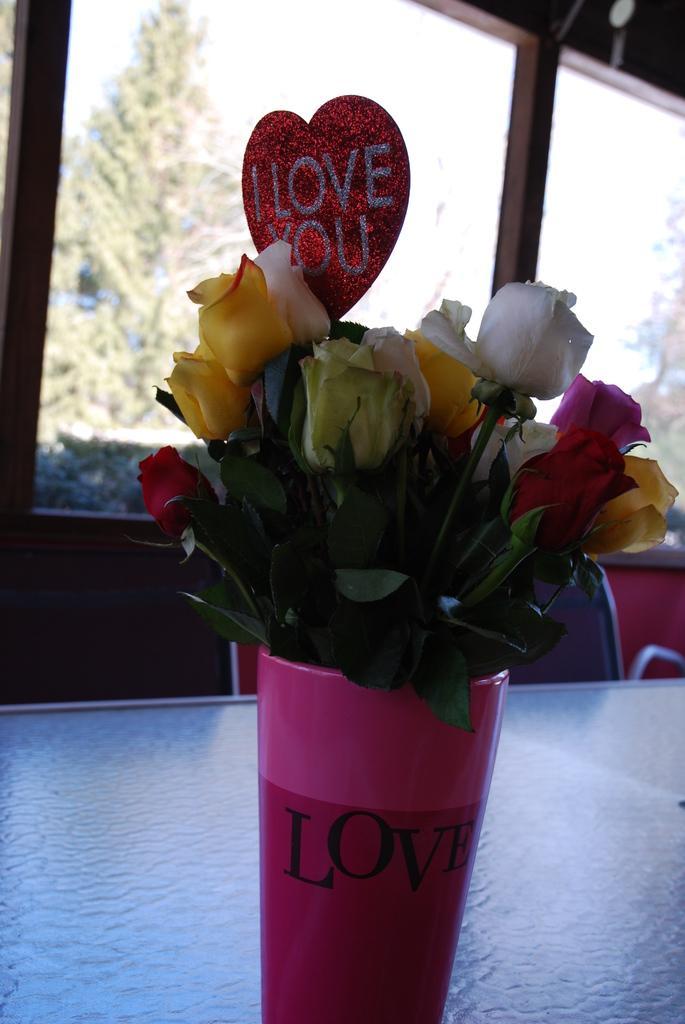Could you give a brief overview of what you see in this image? In this picture we can see a flower vase on a table, chairs, window and from window we can see trees. 